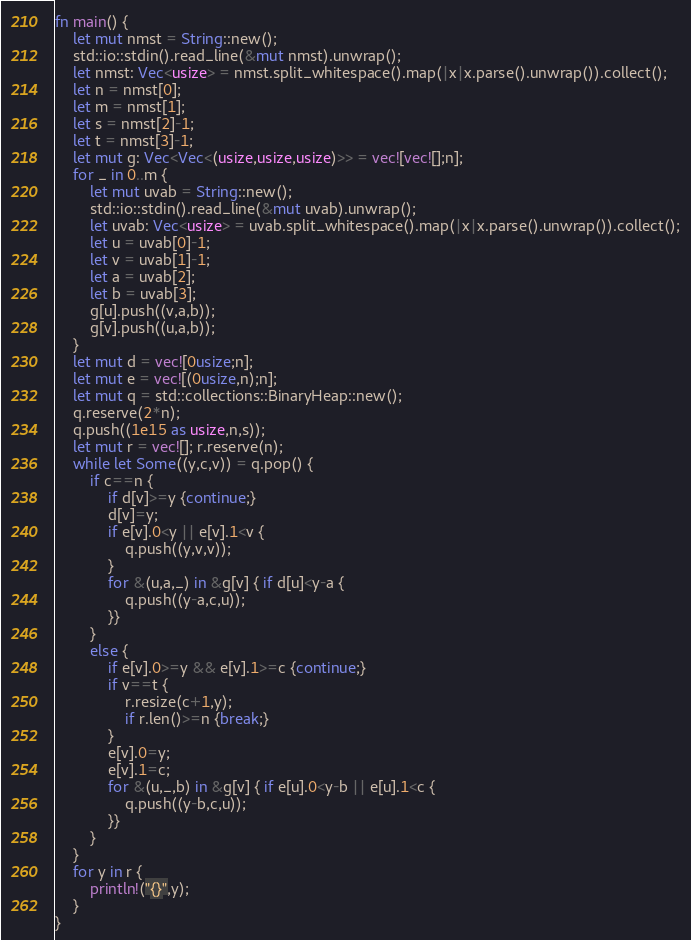<code> <loc_0><loc_0><loc_500><loc_500><_Rust_>fn main() {
    let mut nmst = String::new();
    std::io::stdin().read_line(&mut nmst).unwrap();
    let nmst: Vec<usize> = nmst.split_whitespace().map(|x|x.parse().unwrap()).collect();
    let n = nmst[0];
    let m = nmst[1];
    let s = nmst[2]-1;
    let t = nmst[3]-1;
    let mut g: Vec<Vec<(usize,usize,usize)>> = vec![vec![];n];
    for _ in 0..m {
        let mut uvab = String::new();
        std::io::stdin().read_line(&mut uvab).unwrap();
        let uvab: Vec<usize> = uvab.split_whitespace().map(|x|x.parse().unwrap()).collect();
        let u = uvab[0]-1;
        let v = uvab[1]-1;
        let a = uvab[2];
        let b = uvab[3];
        g[u].push((v,a,b));
        g[v].push((u,a,b));
    }
    let mut d = vec![0usize;n];
    let mut e = vec![(0usize,n);n];
    let mut q = std::collections::BinaryHeap::new();
    q.reserve(2*n);
    q.push((1e15 as usize,n,s));
    let mut r = vec![]; r.reserve(n);
    while let Some((y,c,v)) = q.pop() {
        if c==n {
            if d[v]>=y {continue;}
            d[v]=y;
            if e[v].0<y || e[v].1<v {
                q.push((y,v,v));
            }
            for &(u,a,_) in &g[v] { if d[u]<y-a {
                q.push((y-a,c,u));
            }}
        }
        else {
            if e[v].0>=y && e[v].1>=c {continue;}
            if v==t {
                r.resize(c+1,y);
                if r.len()>=n {break;}
            }
            e[v].0=y;
            e[v].1=c;
            for &(u,_,b) in &g[v] { if e[u].0<y-b || e[u].1<c {
                q.push((y-b,c,u));
            }}
        }
    }
    for y in r {
        println!("{}",y);
    }
}</code> 